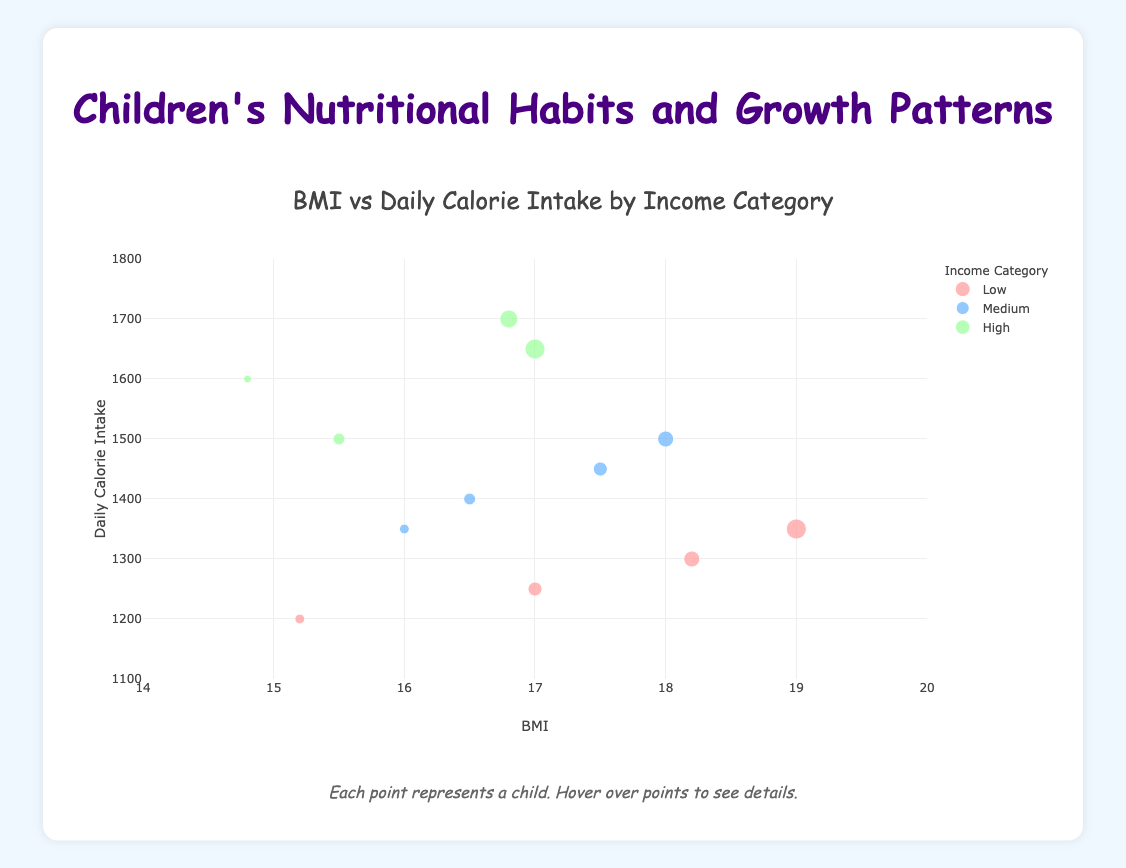What's the title of the plot? The title is prominently displayed at the top of the plot.
Answer: BMI vs Daily Calorie Intake by Income Category What is the range of values for BMI on the x-axis? The x-axis range is specified on the plot. It ranges from 14 to 20.
Answer: 14 to 20 How many children belong to the 'Low' income category? Identify the markers differentiated by color corresponding to the 'Low' income category. Each category has a distinct color.
Answer: 4 Which BMI range has the highest daily calorie intake for the 'High' income category? Look at the 'High' income category markers and find the one with the highest y-value (daily calorie intake) and observe its x-value (BMI).
Answer: Between 16 and 17 Compare the average BMI of children in the 'Medium' income category to those in the 'High' income category. First, identify and list the BMIs for children in both 'Medium' and 'High' categories. Then, calculate the average for each group and compare. Medium BMIs: 16.5, 16.0, 17.5, 18.0 High BMIs: 14.8, 15.5, 16.8, 17.0 Average of Medium: (16.5 + 16.0 + 17.5 + 18.0) / 4 = 17 Average of High: (14.8 + 15.5 + 16.8 + 17.0) / 4 = 16.025
Answer: Medium Which group has a marker that represents the oldest child? Hover over each marker to see the details of the child, including their age. The income category of the oldest child will be shown.
Answer: Low Is there any child in the 'Low' income category with a daily calorie intake above 1400? Look at the y-values (daily calorie intake) of markers in the 'Low' income category and see if any exceed 1400.
Answer: No What is the BMI of the child with the highest daily calorie intake? Identify the marker with the highest y-value (daily calorie intake) and note its x-value (BMI).
Answer: 16.8 How does the daily calorie intake of children aged 8 differ across income categories? Identify markers representing children aged 8 and compare their y-values (daily calorie intake) according to their income categories ('Low', 'Medium', 'High').
Answer: Low: 1300, Medium: 1500, High: None 